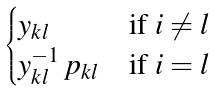Convert formula to latex. <formula><loc_0><loc_0><loc_500><loc_500>\begin{cases} y _ { k l } & \text {if $i \ne l$} \\ y _ { k l } ^ { - 1 } \, p _ { k l } & \text {if $i = l$} \end{cases}</formula> 